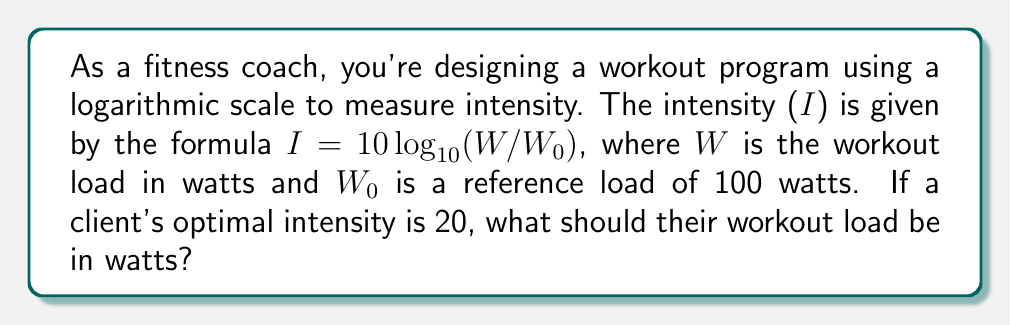Can you solve this math problem? Let's approach this step-by-step:

1) We're given the formula: $I = 10 \log_{10}(W/W_0)$

2) We know that:
   - $I = 20$ (optimal intensity)
   - $W_0 = 100$ watts (reference load)
   - $W$ is what we need to find

3) Let's substitute the known values into the formula:
   
   $20 = 10 \log_{10}(W/100)$

4) Divide both sides by 10:
   
   $2 = \log_{10}(W/100)$

5) Now, we can apply the inverse function (exponential) to both sides:
   
   $10^2 = W/100$

6) Simplify the left side:
   
   $100 = W/100$

7) Multiply both sides by 100:
   
   $10000 = W$

Therefore, the workout load should be 10000 watts.
Answer: $10000$ watts 